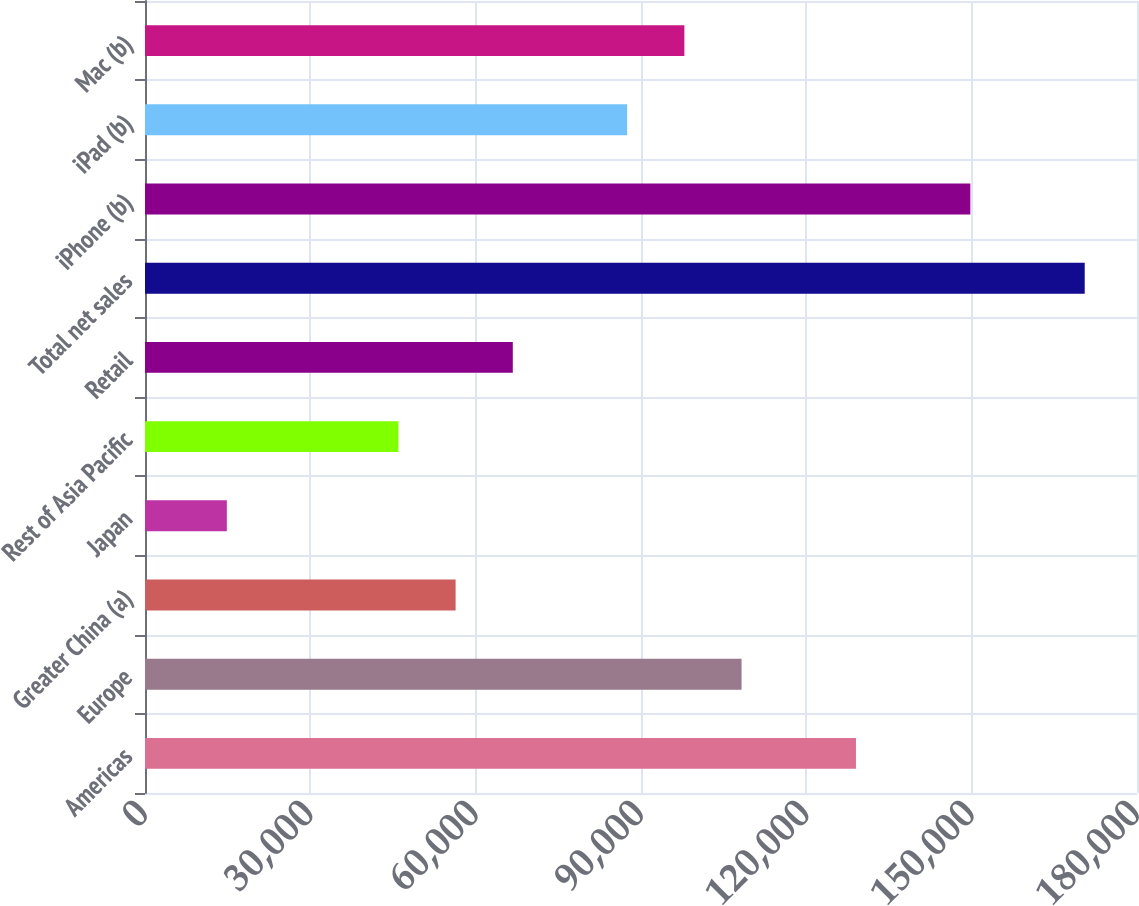<chart> <loc_0><loc_0><loc_500><loc_500><bar_chart><fcel>Americas<fcel>Europe<fcel>Greater China (a)<fcel>Japan<fcel>Rest of Asia Pacific<fcel>Retail<fcel>Total net sales<fcel>iPhone (b)<fcel>iPad (b)<fcel>Mac (b)<nl><fcel>129004<fcel>108249<fcel>56361.5<fcel>14851.5<fcel>45984<fcel>66739<fcel>170514<fcel>149759<fcel>87494<fcel>97871.5<nl></chart> 